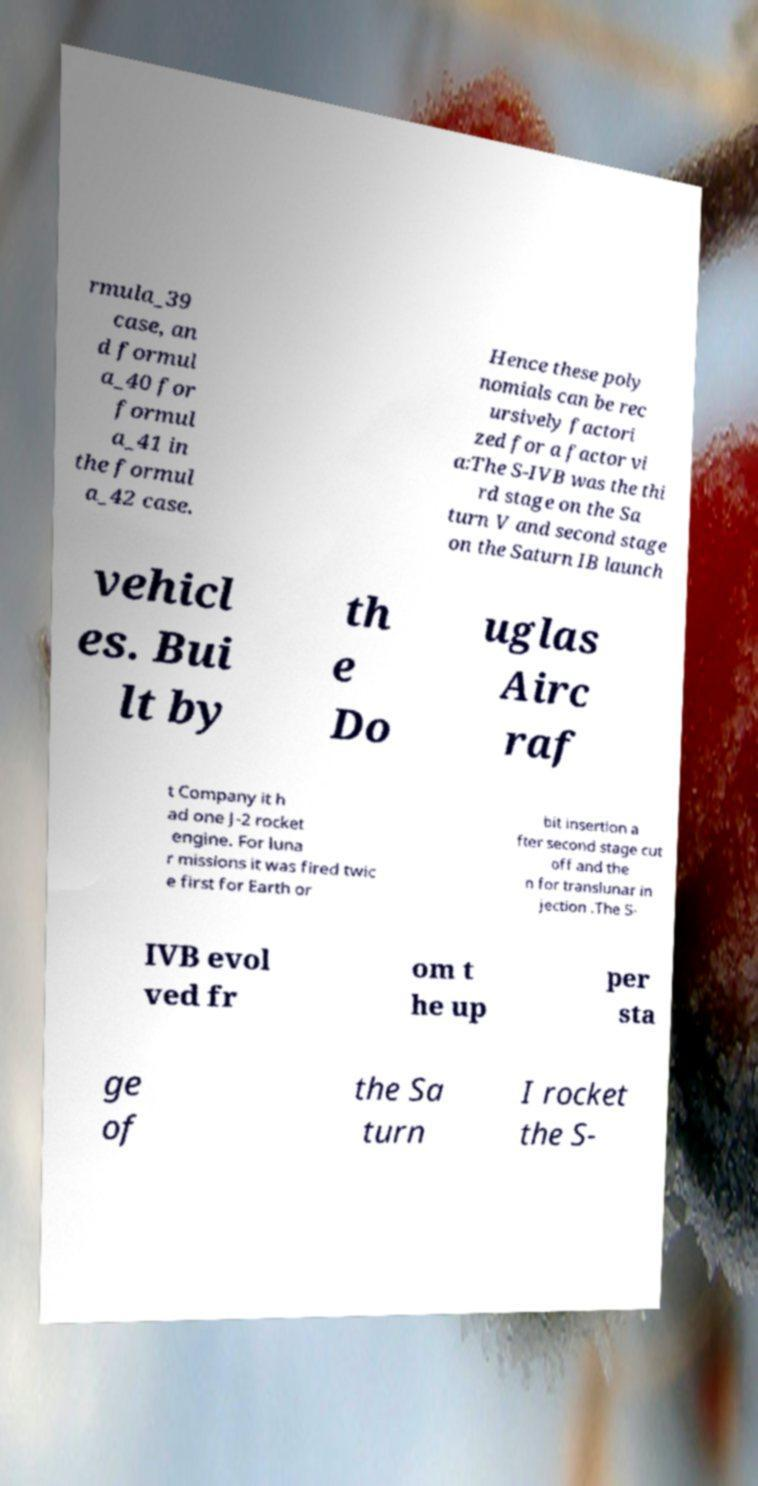Can you read and provide the text displayed in the image?This photo seems to have some interesting text. Can you extract and type it out for me? rmula_39 case, an d formul a_40 for formul a_41 in the formul a_42 case. Hence these poly nomials can be rec ursively factori zed for a factor vi a:The S-IVB was the thi rd stage on the Sa turn V and second stage on the Saturn IB launch vehicl es. Bui lt by th e Do uglas Airc raf t Company it h ad one J-2 rocket engine. For luna r missions it was fired twic e first for Earth or bit insertion a fter second stage cut off and the n for translunar in jection .The S- IVB evol ved fr om t he up per sta ge of the Sa turn I rocket the S- 